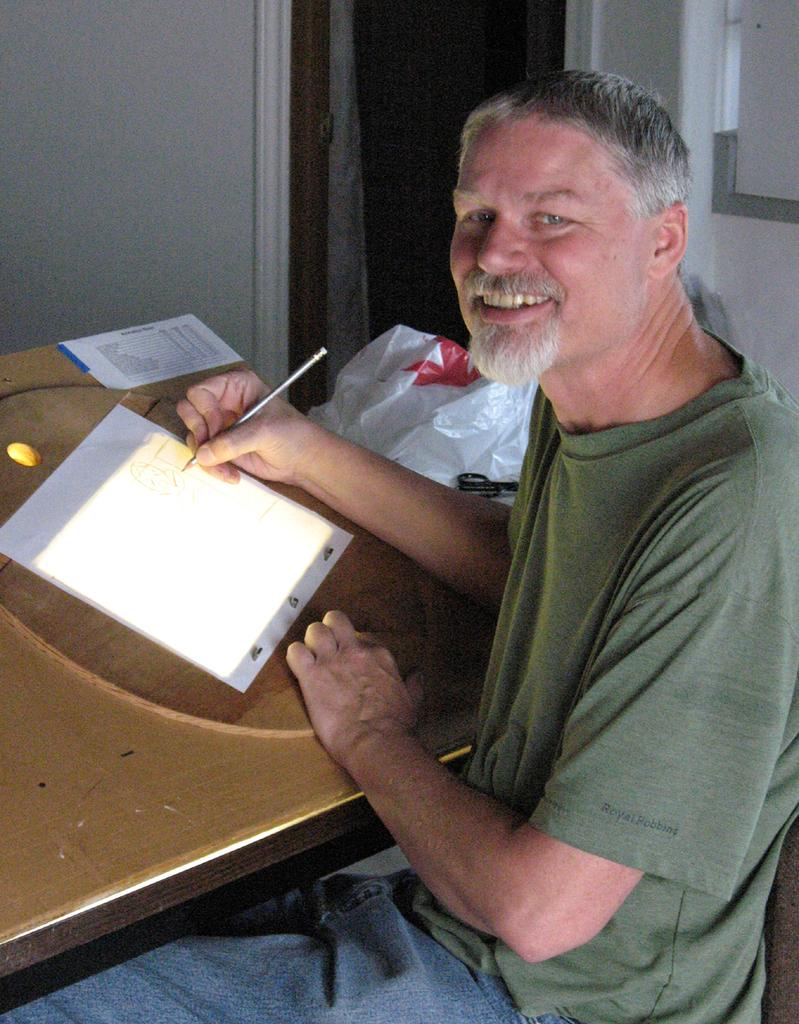What is the main subject of the image? There is a person in the image. What is the person wearing? The person is wearing a green shirt and blue jeans. What is the person doing in the image? The person is sitting on a chair. What other furniture is present in the image? There is a table in the image. What is on the table? There is an object on the table. What type of ice system is being used by the person in the image? There is no ice system present in the image; the person is simply sitting on a chair. 